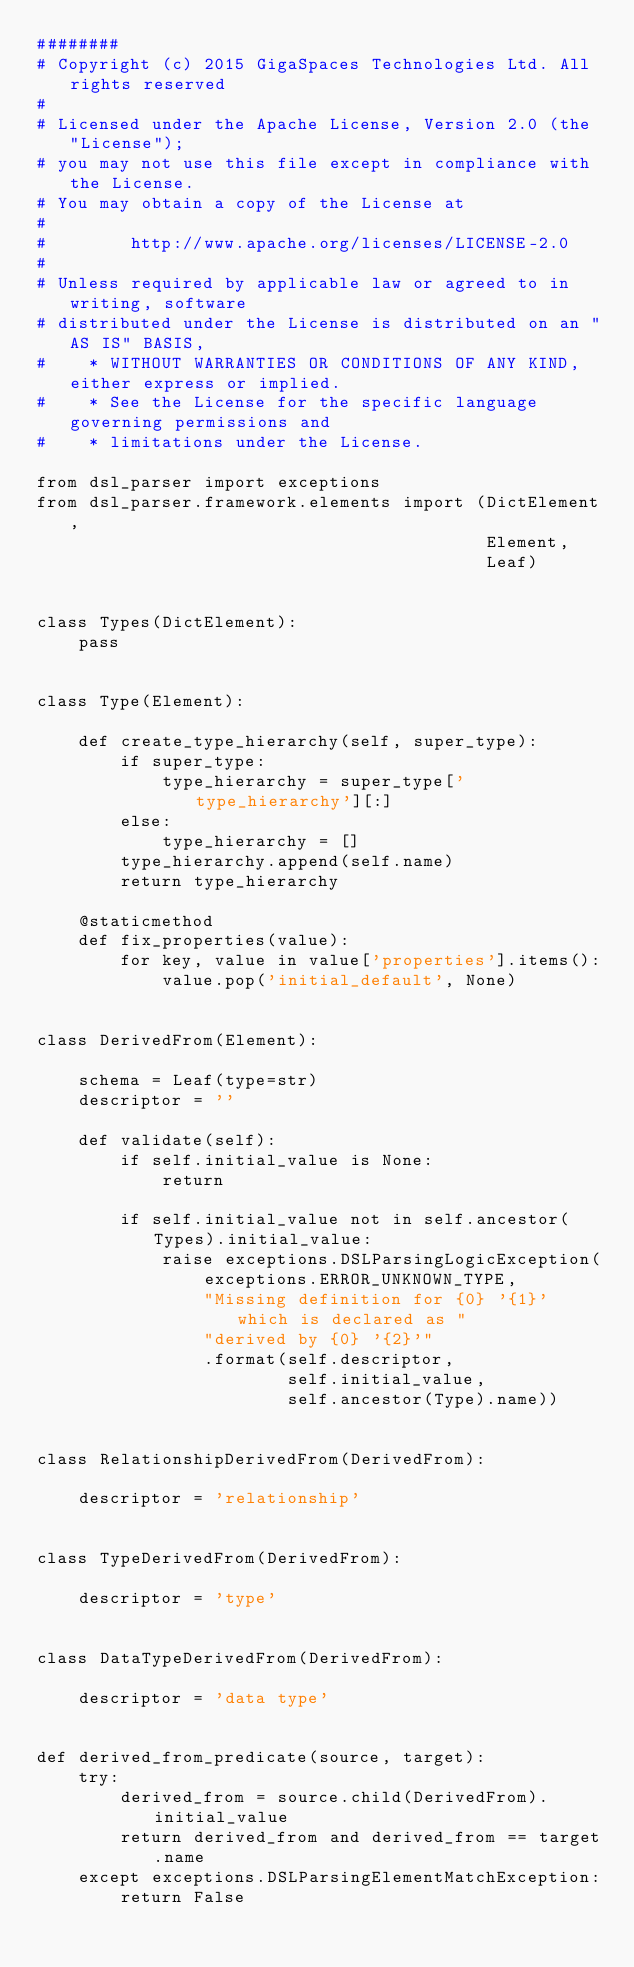Convert code to text. <code><loc_0><loc_0><loc_500><loc_500><_Python_>########
# Copyright (c) 2015 GigaSpaces Technologies Ltd. All rights reserved
#
# Licensed under the Apache License, Version 2.0 (the "License");
# you may not use this file except in compliance with the License.
# You may obtain a copy of the License at
#
#        http://www.apache.org/licenses/LICENSE-2.0
#
# Unless required by applicable law or agreed to in writing, software
# distributed under the License is distributed on an "AS IS" BASIS,
#    * WITHOUT WARRANTIES OR CONDITIONS OF ANY KIND, either express or implied.
#    * See the License for the specific language governing permissions and
#    * limitations under the License.

from dsl_parser import exceptions
from dsl_parser.framework.elements import (DictElement,
                                           Element,
                                           Leaf)


class Types(DictElement):
    pass


class Type(Element):

    def create_type_hierarchy(self, super_type):
        if super_type:
            type_hierarchy = super_type['type_hierarchy'][:]
        else:
            type_hierarchy = []
        type_hierarchy.append(self.name)
        return type_hierarchy

    @staticmethod
    def fix_properties(value):
        for key, value in value['properties'].items():
            value.pop('initial_default', None)


class DerivedFrom(Element):

    schema = Leaf(type=str)
    descriptor = ''

    def validate(self):
        if self.initial_value is None:
            return

        if self.initial_value not in self.ancestor(Types).initial_value:
            raise exceptions.DSLParsingLogicException(
                exceptions.ERROR_UNKNOWN_TYPE,
                "Missing definition for {0} '{1}' which is declared as "
                "derived by {0} '{2}'"
                .format(self.descriptor,
                        self.initial_value,
                        self.ancestor(Type).name))


class RelationshipDerivedFrom(DerivedFrom):

    descriptor = 'relationship'


class TypeDerivedFrom(DerivedFrom):

    descriptor = 'type'


class DataTypeDerivedFrom(DerivedFrom):

    descriptor = 'data type'


def derived_from_predicate(source, target):
    try:
        derived_from = source.child(DerivedFrom).initial_value
        return derived_from and derived_from == target.name
    except exceptions.DSLParsingElementMatchException:
        return False
</code> 